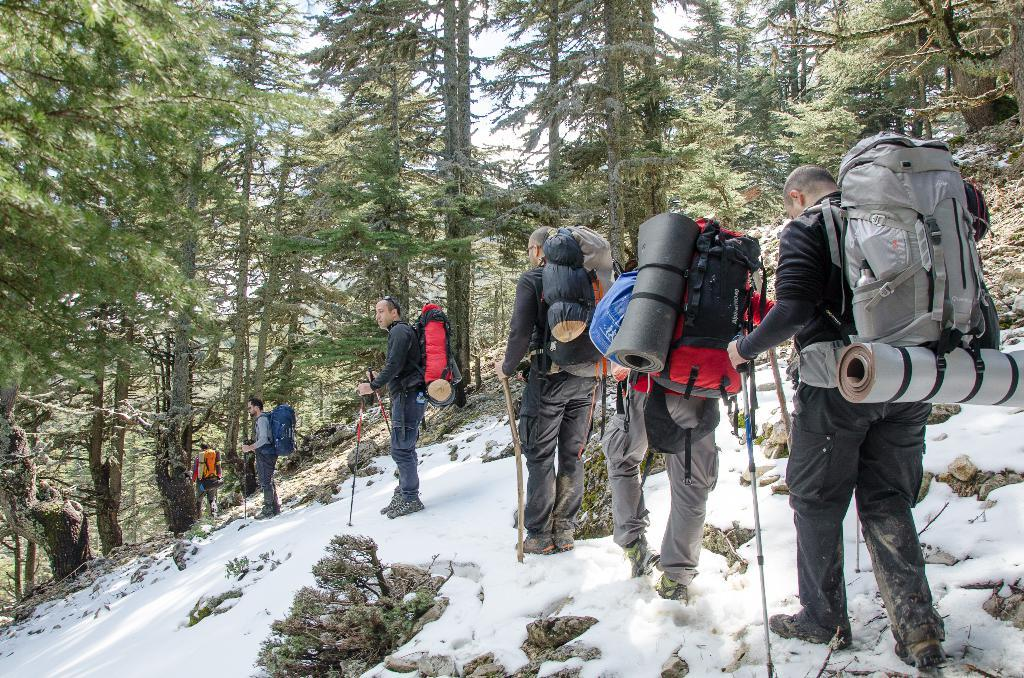Who or what can be seen in the image? There are people in the image. What are the people doing in the image? The people are walking on snow and holding sticks. What are the people wearing in the image? The people are wearing backpacks. What can be seen in the background of the image? There are trees and plants in the image. What type of key can be seen hanging from the tree in the image? There is no key present in the image; it features people walking on snow, holding sticks, and wearing backpacks, with trees and plants in the background. 